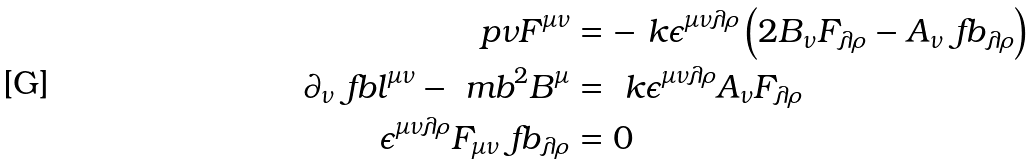Convert formula to latex. <formula><loc_0><loc_0><loc_500><loc_500>\ p \nu F ^ { \mu \nu } & = - \ k \epsilon ^ { \mu \nu \lambda \rho } \left ( 2 B _ { \nu } F _ { \lambda \rho } - A _ { \nu } \ f b _ { \lambda \rho } \right ) \\ \partial _ { \nu } \ f b l ^ { \mu \nu } - \ m b ^ { 2 } B ^ { \mu } & = \ k \epsilon ^ { \mu \nu \lambda \rho } A _ { \nu } F _ { \lambda \rho } \\ \epsilon ^ { \mu \nu \lambda \rho } F _ { \mu \nu } \ f b _ { \lambda \rho } & = 0</formula> 